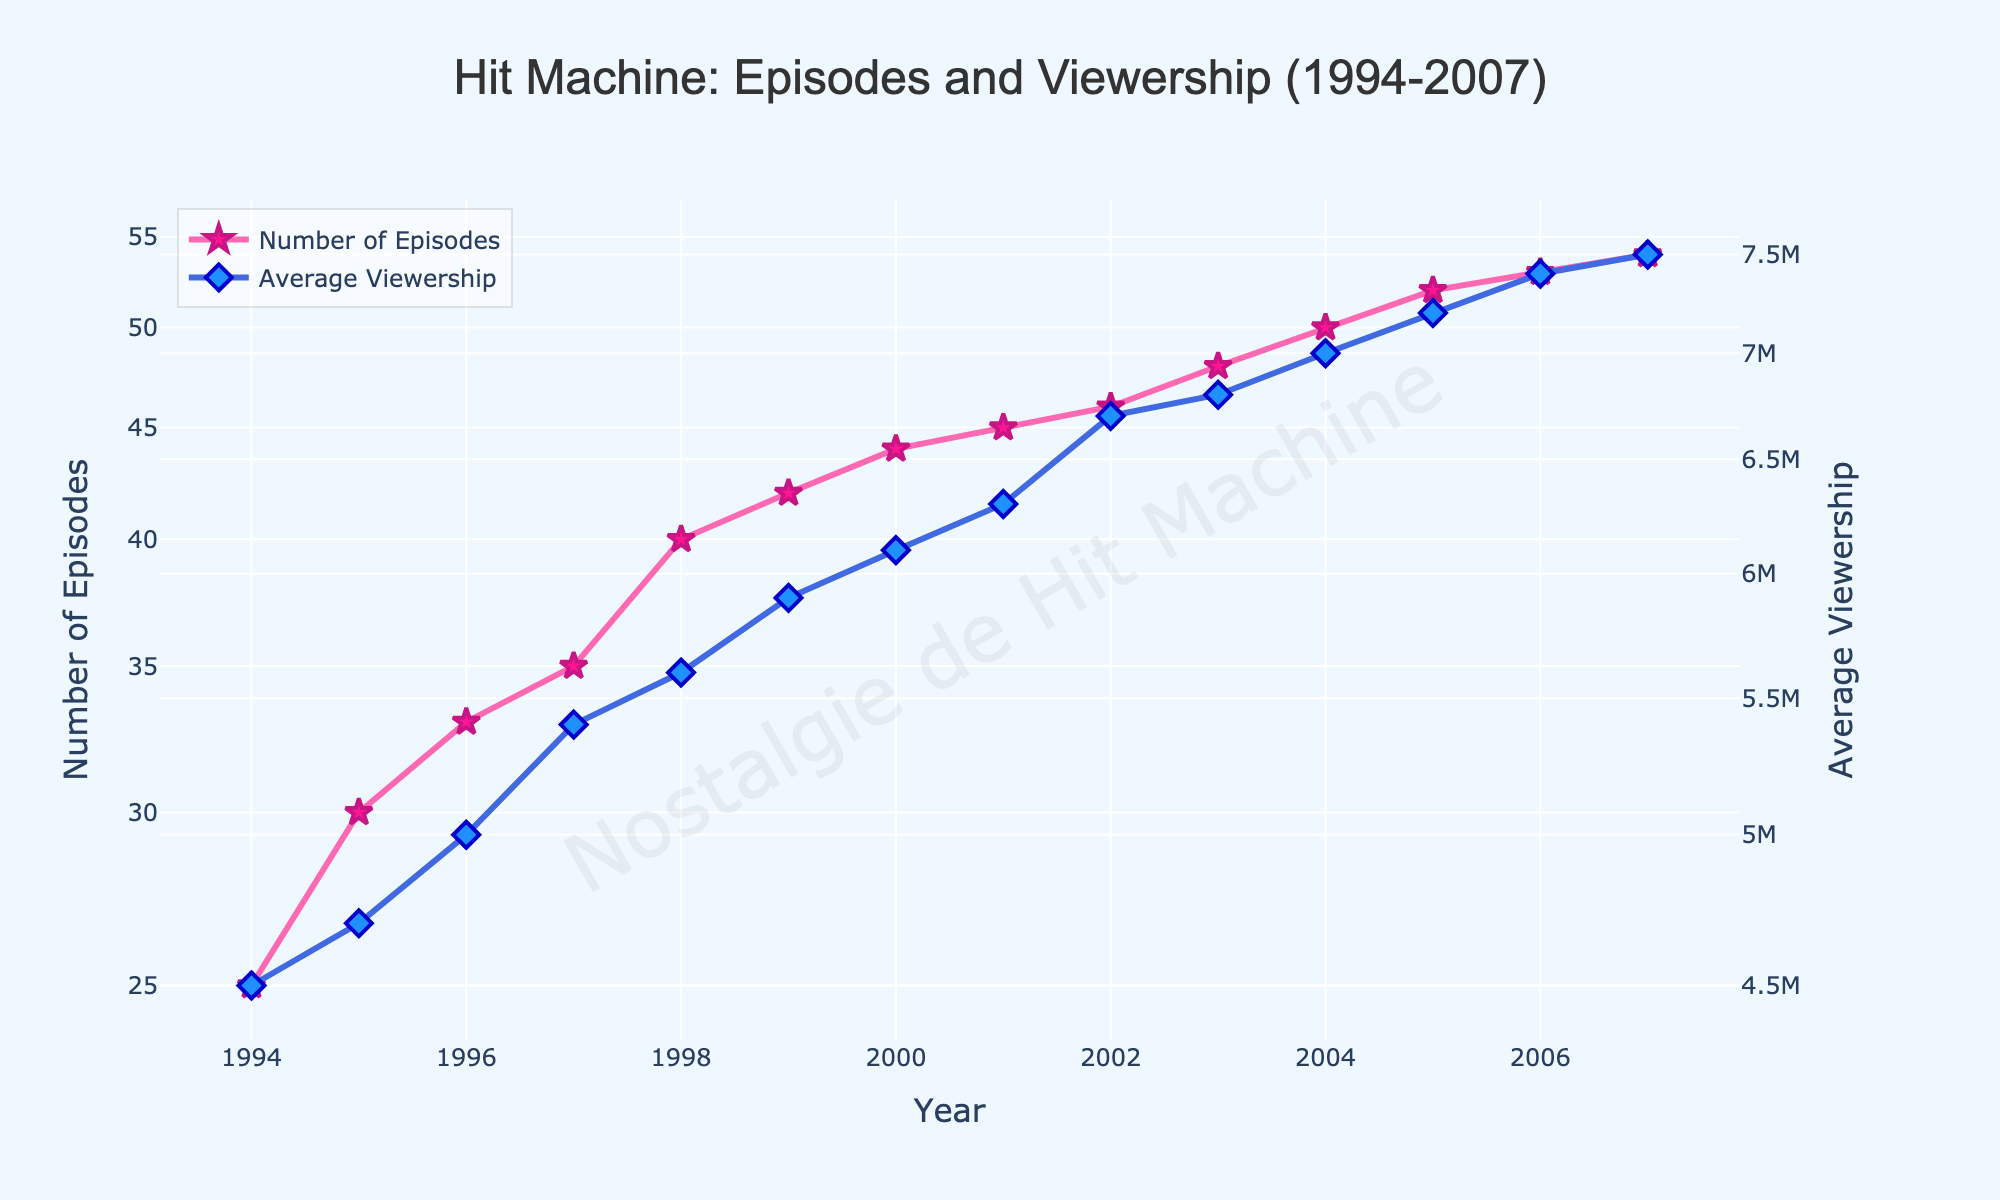What is the title of the plot? The title is usually placed at the top of the plot. In this plot, it is "Hit Machine: Episodes and Viewership (1994-2007)".
Answer: "Hit Machine: Episodes and Viewership (1994-2007)" What are the y-axes labeled as? The y-axes labels are visible on the left and right sides of the plot. The left y-axis is labeled "Number of Episodes" and the right y-axis is labeled "Average Viewership".
Answer: "Number of Episodes" and "Average Viewership" In which year did "Hit Machine" have the highest viewership? By looking at the "Average Viewership" curve, we follow the highest point on the blue line, which is at 2007, with a viewership of 7,500,000.
Answer: 2007 How many episodes were there in 2003? By locating the year 2003 on the x-axis and following it up to the pink curve, we find that there were 48 episodes.
Answer: 48 What is the trend in the number of episodes from 1994 to 2007? Tracing the pink line, we can see that the number of episodes increases over the years, starting from 25 in 1994 and reaching 54 in 2007.
Answer: Increasing What is the difference in average viewership between 2000 and 2003? The average viewership for 2000 is 6.1 million and for 2003 is 6.8 million. The difference is 6.8 - 6.1 = 0.7 million.
Answer: 0.7 million Did the average viewership grow faster before or after 2000? We need to compare the slopes of the blue line before and after 2000. Before 2000, the viewership increases from 4.5 to 6.1 million in 6 years, but after 2000, it rises from 6.3 to 7.5 million in 7 years. The slope is steeper before 2000.
Answer: Before 2000 Which year witnessed the biggest jump in viewership? Observing the year-to-year variations in the blue line, the largest vertical jump happens from 2001 (6.3 million) to 2002 (6.7 million) which is a 0.4 million increase.
Answer: 2001 to 2002 What is the relationship between the number of episodes and average viewership over the years? By comparing the trends, we can see that as the number of episodes increases (pink line), the average viewership generally increases as well (blue line).
Answer: Positive correlation 